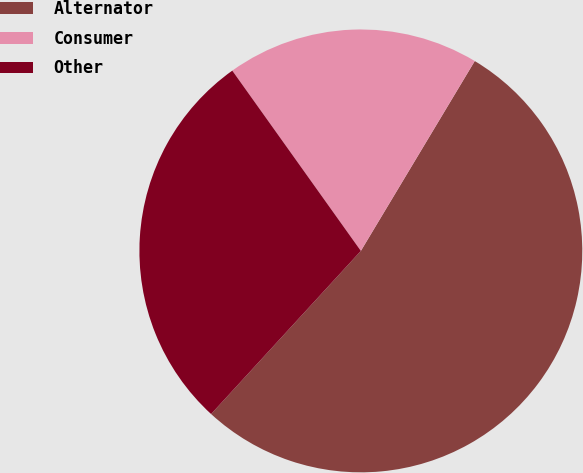<chart> <loc_0><loc_0><loc_500><loc_500><pie_chart><fcel>Alternator<fcel>Consumer<fcel>Other<nl><fcel>53.22%<fcel>18.46%<fcel>28.32%<nl></chart> 